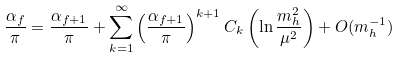Convert formula to latex. <formula><loc_0><loc_0><loc_500><loc_500>\frac { \alpha _ { f } } { \pi } = \frac { \alpha _ { f + 1 } } { \pi } + \sum _ { k = 1 } ^ { \infty } \left ( \frac { \alpha _ { f + 1 } } { \pi } \right ) ^ { k + 1 } C _ { k } \left ( \ln \frac { m _ { h } ^ { 2 } } { \mu ^ { 2 } } \right ) + O ( m _ { h } ^ { - 1 } )</formula> 